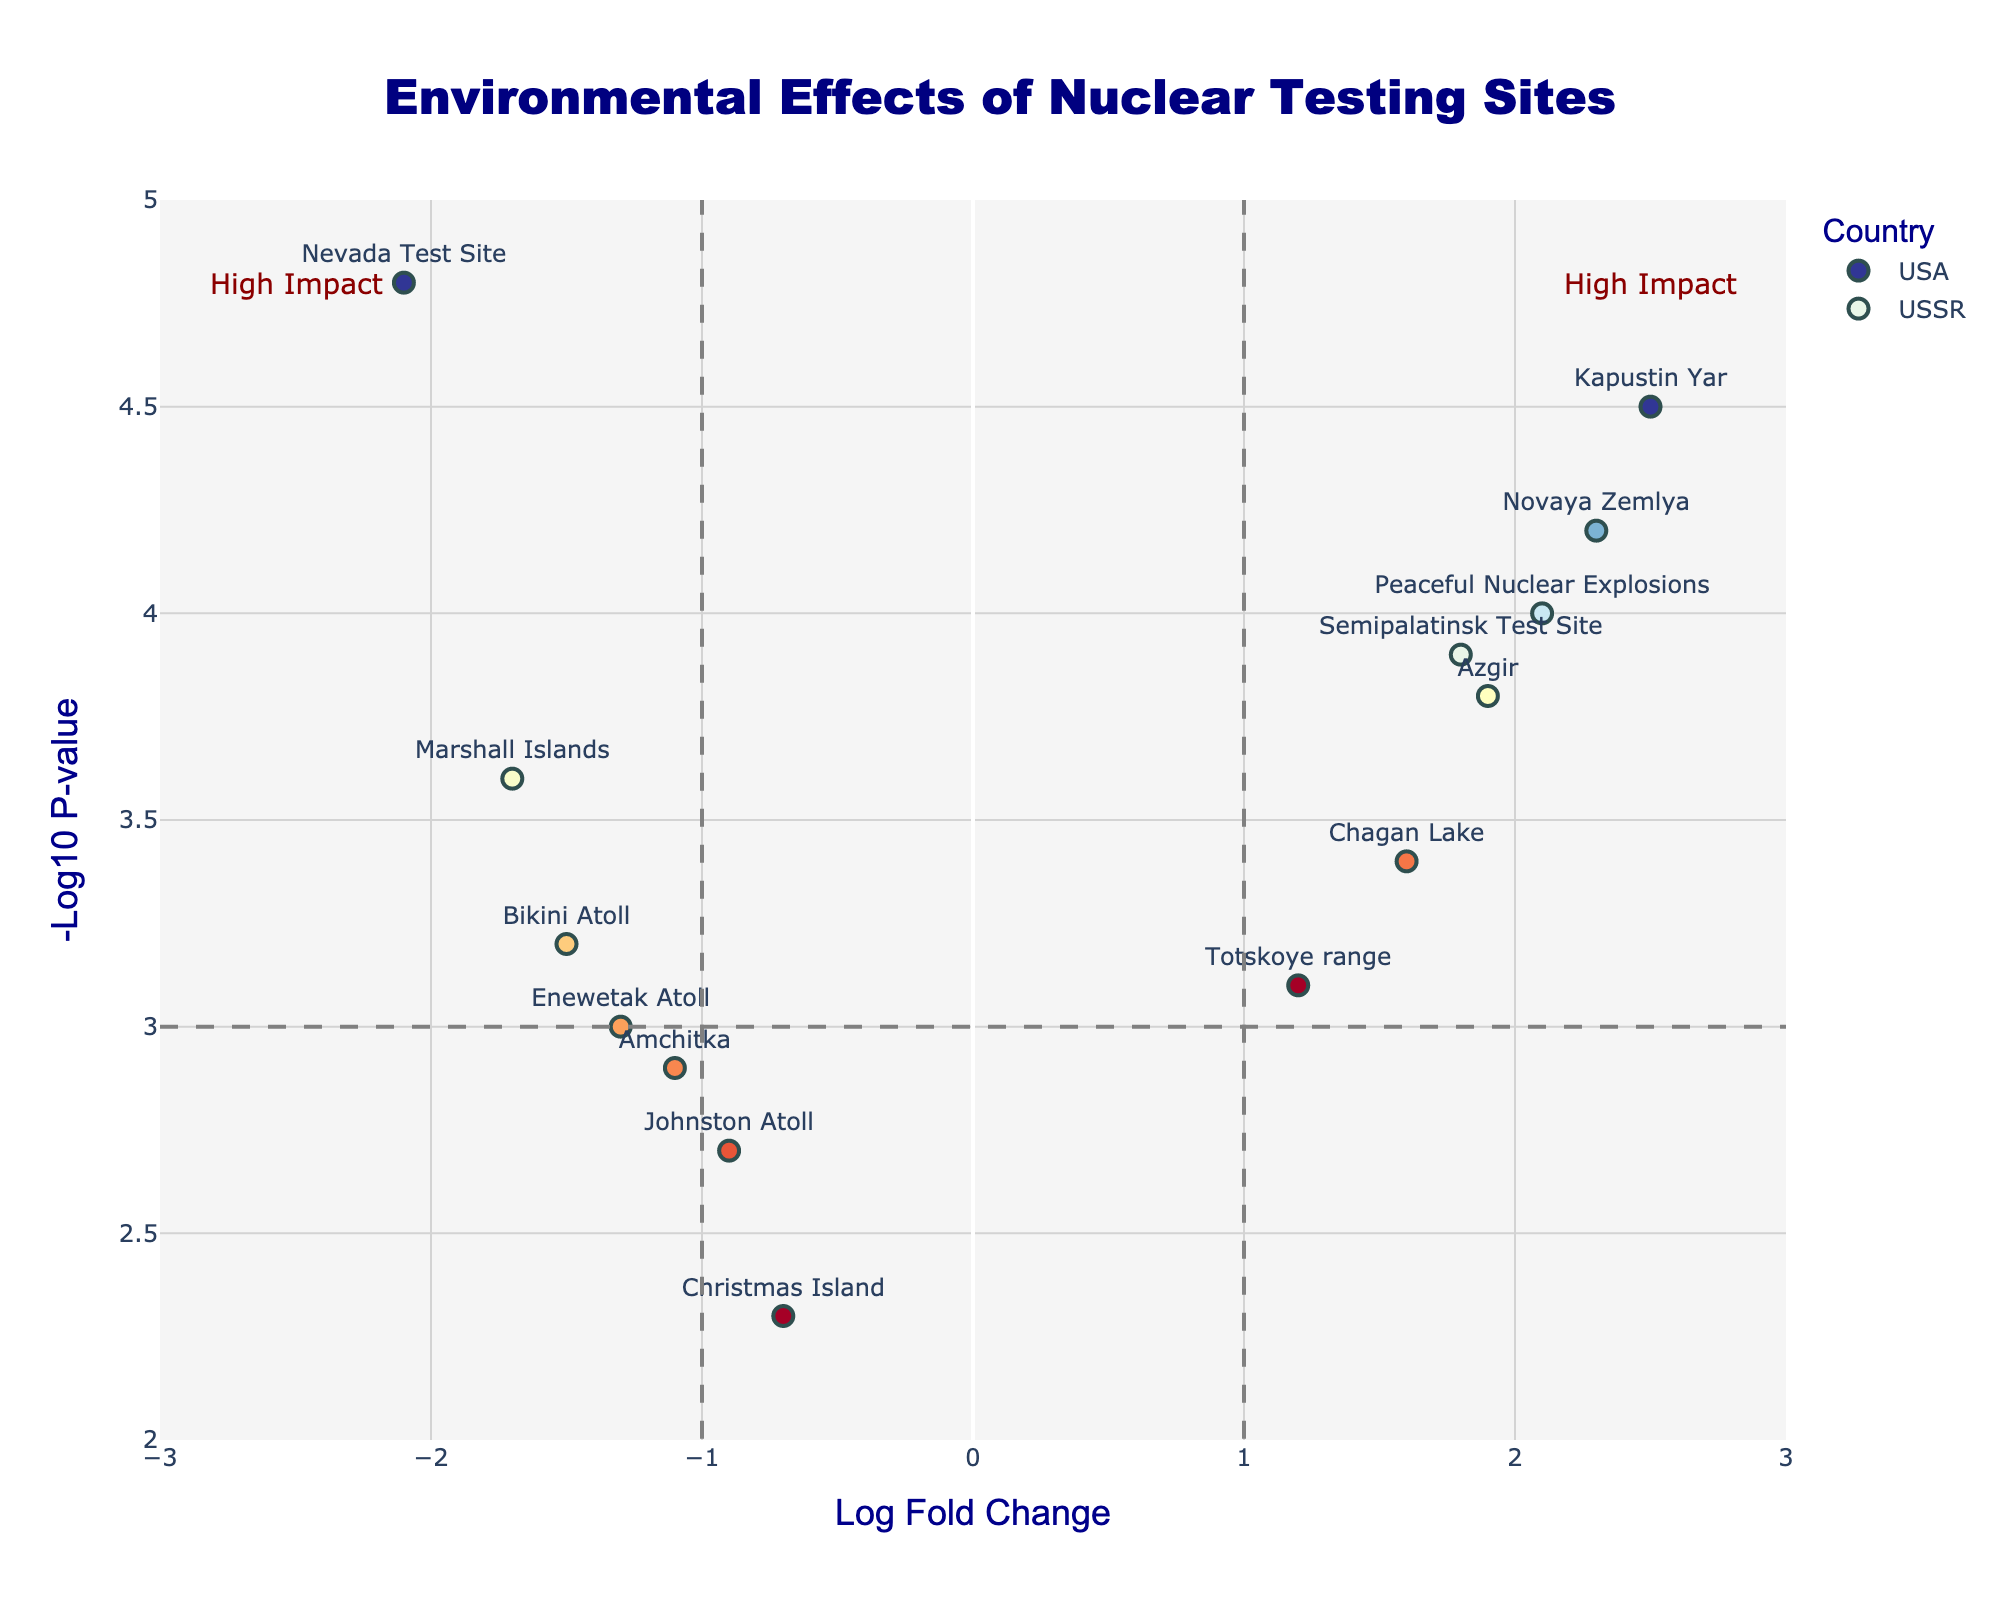How many sites are located in the USA? Count the data points labeled with 'USA' as the country. There are 7 sites labeled as 'USA'.
Answer: 7 Which country has the site with the highest negative log P-value? Look for the highest value on the y-axis (-Log10 P-value) and check the corresponding country. It is the 'Nevada Test Site' in the USA with a value of 4.8.
Answer: USA What is the range of the Log Fold Change axis? Identify the minimum and maximum values on the x-axis labelled 'Log Fold Change'. The range is from -3 to 3.
Answer: -3 to 3 Which site has the lowest negative Log P-value and which country is it in? Find the point with the smallest y-value and note its label and country. The 'Christmas Island' in the USA has the lowest negative log P-value of 2.3.
Answer: Christmas Island, USA What is the difference in negative Log P-value between 'Kapustin Yar' and 'Amchitka'? Find and subtract the y-values for 'Kapustin Yar' (4.5) and 'Amchitka' (2.9). The difference is 4.5 - 2.9 = 1.6.
Answer: 1.6 Are there more sites with a positive Log Fold Change in the USSR or the USA? Compare the number of data points to the right of the y-axis (Log Fold Change > 0) for both countries. USSR has 7 sites and USA has none.
Answer: USSR How many sites have a Log Fold Change greater than 2? Count the data points where the x-value (Log Fold Change) is greater than 2. There are two sites: 'Novaya Zemlya' and 'Kapustin Yar'.
Answer: 2 Which country has the majority of high impact sites based on the negative Log P-value greater than 3? Count the sites with y-values greater than 3 for both countries. USSR has 6 such sites, while the USA has 4.
Answer: USSR Which site has the highest Log Fold Change and what is its corresponding negative Log P-value? Identify the point with the highest x-value (Log Fold Change). It is 'Kapustin Yar' with a corresponding negative Log P-value of 4.5.
Answer: Kapustin Yar, 4.5 